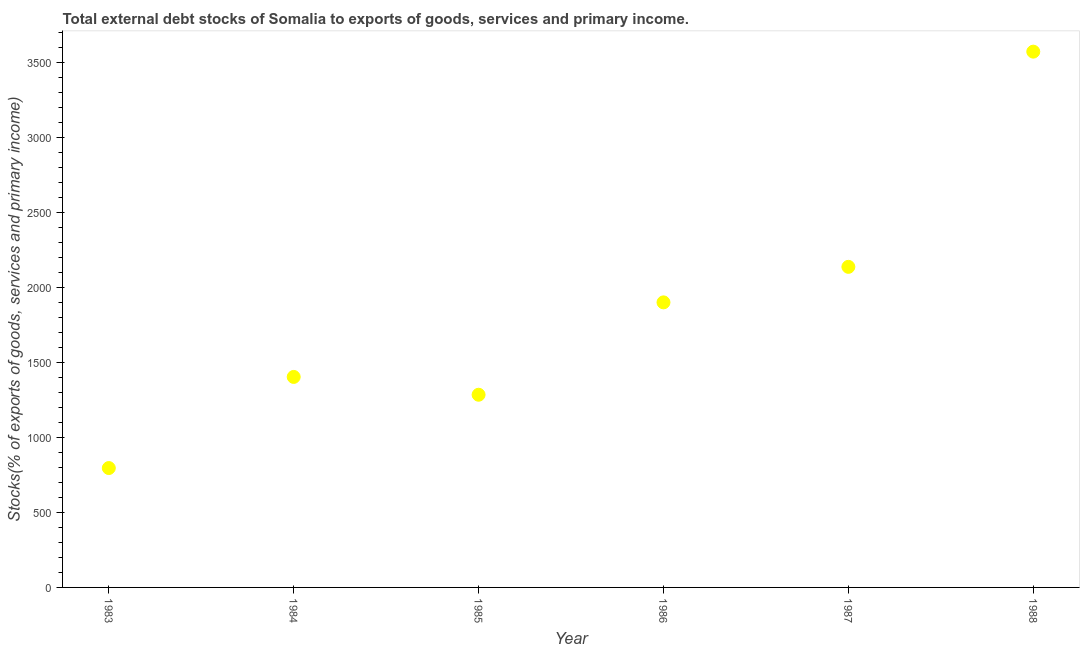What is the external debt stocks in 1986?
Ensure brevity in your answer.  1900.56. Across all years, what is the maximum external debt stocks?
Make the answer very short. 3572.21. Across all years, what is the minimum external debt stocks?
Your answer should be compact. 795.87. What is the sum of the external debt stocks?
Provide a succinct answer. 1.11e+04. What is the difference between the external debt stocks in 1987 and 1988?
Offer a terse response. -1434.82. What is the average external debt stocks per year?
Your answer should be compact. 1849.03. What is the median external debt stocks?
Make the answer very short. 1652.01. Do a majority of the years between 1986 and 1985 (inclusive) have external debt stocks greater than 1100 %?
Ensure brevity in your answer.  No. What is the ratio of the external debt stocks in 1986 to that in 1988?
Your answer should be compact. 0.53. Is the external debt stocks in 1987 less than that in 1988?
Keep it short and to the point. Yes. What is the difference between the highest and the second highest external debt stocks?
Make the answer very short. 1434.82. What is the difference between the highest and the lowest external debt stocks?
Provide a short and direct response. 2776.34. Are the values on the major ticks of Y-axis written in scientific E-notation?
Provide a succinct answer. No. Does the graph contain any zero values?
Offer a very short reply. No. Does the graph contain grids?
Ensure brevity in your answer.  No. What is the title of the graph?
Provide a succinct answer. Total external debt stocks of Somalia to exports of goods, services and primary income. What is the label or title of the Y-axis?
Give a very brief answer. Stocks(% of exports of goods, services and primary income). What is the Stocks(% of exports of goods, services and primary income) in 1983?
Keep it short and to the point. 795.87. What is the Stocks(% of exports of goods, services and primary income) in 1984?
Provide a succinct answer. 1403.46. What is the Stocks(% of exports of goods, services and primary income) in 1985?
Provide a short and direct response. 1284.68. What is the Stocks(% of exports of goods, services and primary income) in 1986?
Give a very brief answer. 1900.56. What is the Stocks(% of exports of goods, services and primary income) in 1987?
Provide a short and direct response. 2137.39. What is the Stocks(% of exports of goods, services and primary income) in 1988?
Provide a succinct answer. 3572.21. What is the difference between the Stocks(% of exports of goods, services and primary income) in 1983 and 1984?
Give a very brief answer. -607.59. What is the difference between the Stocks(% of exports of goods, services and primary income) in 1983 and 1985?
Provide a short and direct response. -488.81. What is the difference between the Stocks(% of exports of goods, services and primary income) in 1983 and 1986?
Provide a succinct answer. -1104.69. What is the difference between the Stocks(% of exports of goods, services and primary income) in 1983 and 1987?
Your answer should be compact. -1341.52. What is the difference between the Stocks(% of exports of goods, services and primary income) in 1983 and 1988?
Keep it short and to the point. -2776.34. What is the difference between the Stocks(% of exports of goods, services and primary income) in 1984 and 1985?
Provide a succinct answer. 118.78. What is the difference between the Stocks(% of exports of goods, services and primary income) in 1984 and 1986?
Provide a short and direct response. -497.1. What is the difference between the Stocks(% of exports of goods, services and primary income) in 1984 and 1987?
Provide a short and direct response. -733.93. What is the difference between the Stocks(% of exports of goods, services and primary income) in 1984 and 1988?
Provide a succinct answer. -2168.75. What is the difference between the Stocks(% of exports of goods, services and primary income) in 1985 and 1986?
Keep it short and to the point. -615.87. What is the difference between the Stocks(% of exports of goods, services and primary income) in 1985 and 1987?
Your answer should be very brief. -852.71. What is the difference between the Stocks(% of exports of goods, services and primary income) in 1985 and 1988?
Provide a short and direct response. -2287.53. What is the difference between the Stocks(% of exports of goods, services and primary income) in 1986 and 1987?
Make the answer very short. -236.84. What is the difference between the Stocks(% of exports of goods, services and primary income) in 1986 and 1988?
Give a very brief answer. -1671.65. What is the difference between the Stocks(% of exports of goods, services and primary income) in 1987 and 1988?
Give a very brief answer. -1434.82. What is the ratio of the Stocks(% of exports of goods, services and primary income) in 1983 to that in 1984?
Provide a short and direct response. 0.57. What is the ratio of the Stocks(% of exports of goods, services and primary income) in 1983 to that in 1985?
Provide a succinct answer. 0.62. What is the ratio of the Stocks(% of exports of goods, services and primary income) in 1983 to that in 1986?
Offer a terse response. 0.42. What is the ratio of the Stocks(% of exports of goods, services and primary income) in 1983 to that in 1987?
Provide a succinct answer. 0.37. What is the ratio of the Stocks(% of exports of goods, services and primary income) in 1983 to that in 1988?
Provide a succinct answer. 0.22. What is the ratio of the Stocks(% of exports of goods, services and primary income) in 1984 to that in 1985?
Provide a short and direct response. 1.09. What is the ratio of the Stocks(% of exports of goods, services and primary income) in 1984 to that in 1986?
Your answer should be very brief. 0.74. What is the ratio of the Stocks(% of exports of goods, services and primary income) in 1984 to that in 1987?
Keep it short and to the point. 0.66. What is the ratio of the Stocks(% of exports of goods, services and primary income) in 1984 to that in 1988?
Your response must be concise. 0.39. What is the ratio of the Stocks(% of exports of goods, services and primary income) in 1985 to that in 1986?
Provide a succinct answer. 0.68. What is the ratio of the Stocks(% of exports of goods, services and primary income) in 1985 to that in 1987?
Provide a succinct answer. 0.6. What is the ratio of the Stocks(% of exports of goods, services and primary income) in 1985 to that in 1988?
Your answer should be compact. 0.36. What is the ratio of the Stocks(% of exports of goods, services and primary income) in 1986 to that in 1987?
Provide a succinct answer. 0.89. What is the ratio of the Stocks(% of exports of goods, services and primary income) in 1986 to that in 1988?
Provide a short and direct response. 0.53. What is the ratio of the Stocks(% of exports of goods, services and primary income) in 1987 to that in 1988?
Give a very brief answer. 0.6. 